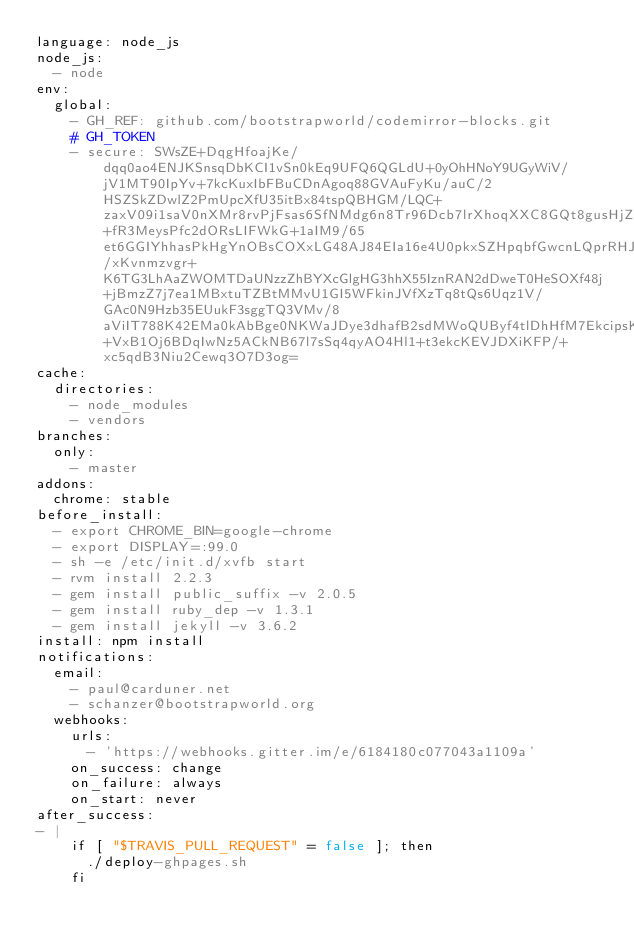<code> <loc_0><loc_0><loc_500><loc_500><_YAML_>language: node_js
node_js:
  - node
env:
  global:
    - GH_REF: github.com/bootstrapworld/codemirror-blocks.git
    # GH_TOKEN
    - secure: SWsZE+DqgHfoajKe/dqq0ao4ENJKSnsqDbKCI1vSn0kEq9UFQ6QGLdU+0yOhHNoY9UGyWiV/jV1MT90IpYv+7kcKuxIbFBuCDnAgoq88GVAuFyKu/auC/2HSZSkZDwlZ2PmUpcXfU35itBx84tspQBHGM/LQC+zaxV09i1saV0nXMr8rvPjFsas6SfNMdg6n8Tr96Dcb7lrXhoqXXC8GQt8gusHjZY+fR3MeysPfc2dORsLIFWkG+1aIM9/65et6GGIYhhasPkHgYnOBsCOXxLG48AJ84EIa16e4U0pkxSZHpqbfGwcnLQprRHJ46jGI7khgSxsigejpIgZcnD4gAyYocM1h9WTW2YmE813gK1Vrw0jieEx8Gy/xKvnmzvgr+K6TG3LhAaZWOMTDaUNzzZhBYXcGlgHG3hhX55IznRAN2dDweT0HeSOXf48j+jBmzZ7j7ea1MBxtuTZBtMMvU1GI5WFkinJVfXzTq8tQs6Uqz1V/GAc0N9Hzb35EUukF3sggTQ3VMv/8aViIT788K42EMa0kAbBge0NKWaJDye3dhafB2sdMWoQUByf4tlDhHfM7EkcipsKhDlauLSRa0I8BTrSTNh+VxB1Oj6BDqIwNz5ACkNB67l7sSq4qyAO4Hl1+t3ekcKEVJDXiKFP/+xc5qdB3Niu2Cewq3O7D3og=
cache:
  directories:
    - node_modules
    - vendors
branches:
  only:
    - master
addons:
  chrome: stable
before_install:
  - export CHROME_BIN=google-chrome
  - export DISPLAY=:99.0
  - sh -e /etc/init.d/xvfb start
  - rvm install 2.2.3
  - gem install public_suffix -v 2.0.5
  - gem install ruby_dep -v 1.3.1
  - gem install jekyll -v 3.6.2
install: npm install
notifications:
  email:
    - paul@carduner.net
    - schanzer@bootstrapworld.org
  webhooks:
    urls:
      - 'https://webhooks.gitter.im/e/6184180c077043a1109a'
    on_success: change
    on_failure: always
    on_start: never
after_success:
- |
    if [ "$TRAVIS_PULL_REQUEST" = false ]; then
      ./deploy-ghpages.sh
    fi
</code> 